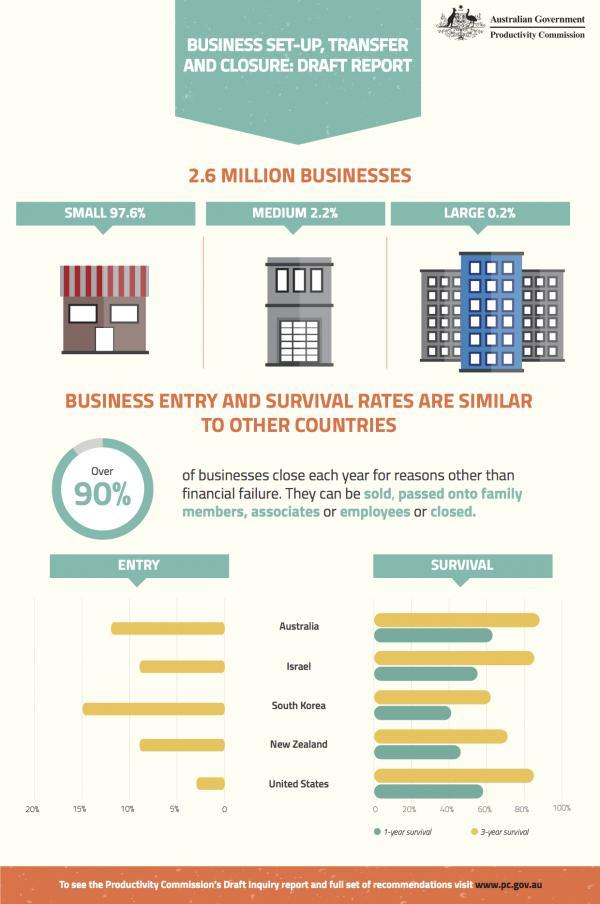How many countries shown in the graph have 3-year survival rates above 80%?
Answer the question with a short phrase. 3 Which country has the second highest business entry rates? Australia How many countries have business entry rates between 5-10%? 2 Which country has 1-year survival rate above 60%? Australia How many countries shown in the graph have business entry rates above 10%? 2 Which country has business entry rate less than 5%? United States Which two countries have business entry rates between 5-10%? Israel, New Zealand What is the approximate 3-year survival rate for businesses in New Zealand? 70% The 1-year survival rate of Australia is higher than the 3-year survival rate of which country? South Korea Which country shown in the graph has the second lowest 1-year survival rate? New Zealand 